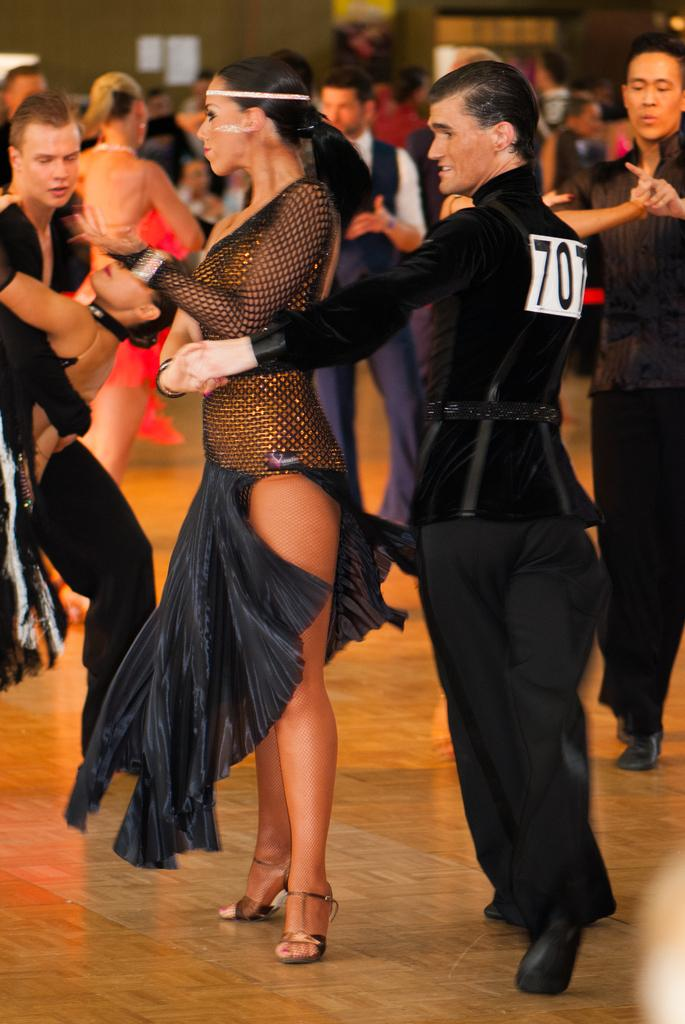How many people are in the image? There are people in the image, but the exact number is not specified. What are the people in the image doing? The people in the image are standing. What type of button can be seen on the person's shirt in the image? There is no information about buttons or clothing in the provided facts, so it cannot be determined from the image. 